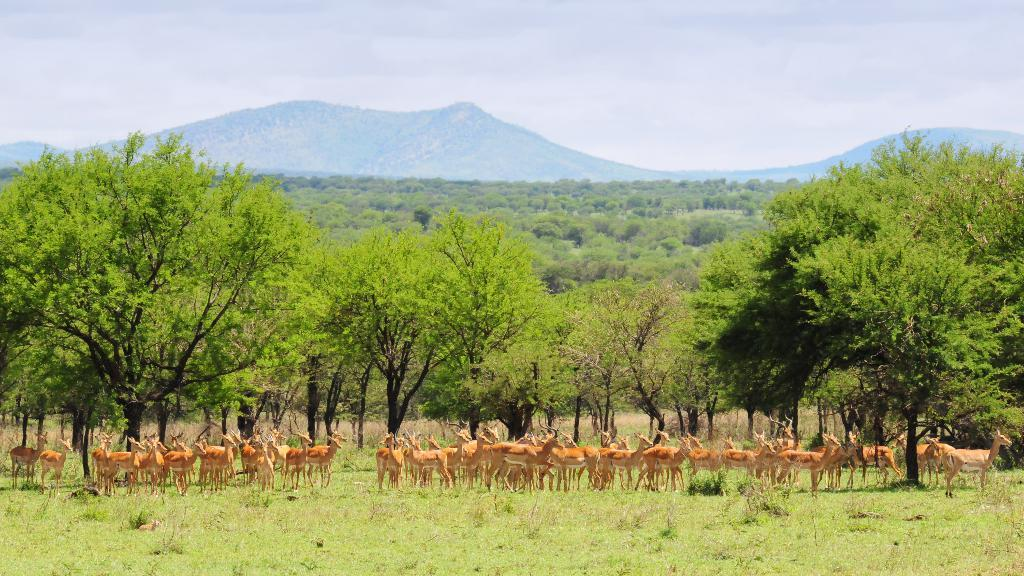What animals are present in the image? There are many deer in the image. Where are the deer located? The deer are on the grass. What can be seen behind the deer? There are trees behind the deer. What is visible in the background of the image? There are hills in the background of the image. What is visible at the top of the image? The sky is visible at the top of the image. What hobbies do the deer have in the image? The image does not provide information about the hobbies of the deer, as they are wild animals and not engaged in any human activities. 